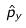<formula> <loc_0><loc_0><loc_500><loc_500>\hat { p } _ { y }</formula> 